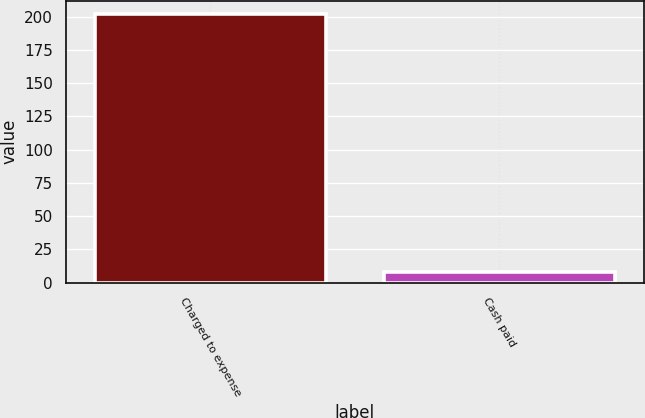<chart> <loc_0><loc_0><loc_500><loc_500><bar_chart><fcel>Charged to expense<fcel>Cash paid<nl><fcel>202<fcel>8<nl></chart> 